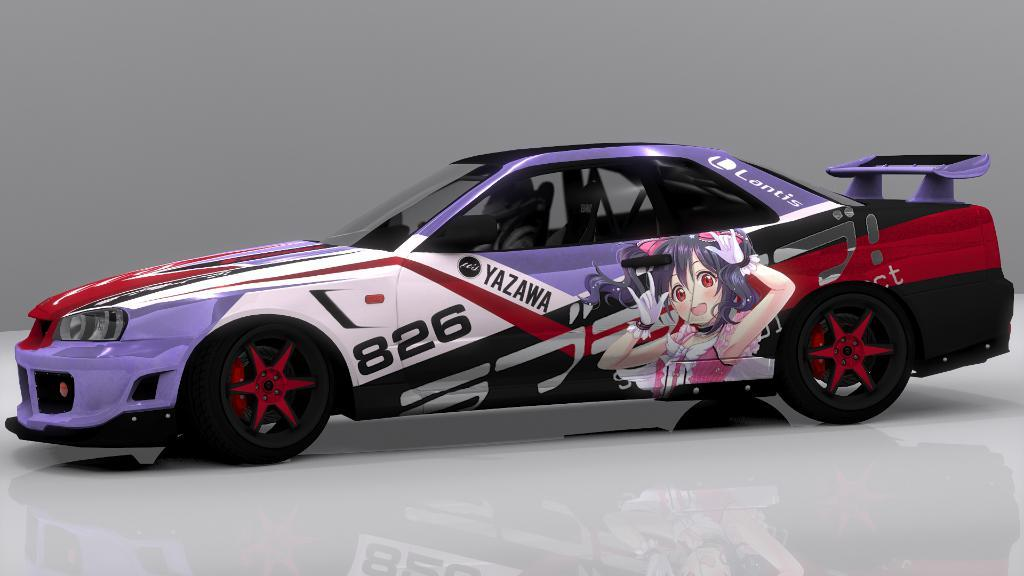What is the main subject of the image? The main subject of the image is a car. What is the color of the background in the image? The background of the image is white. What type of point is being made by the car in the image? There is no indication in the image that the car is making any point. Who is the expert in the image? There is no expert present in the image; it only features a car. What role does the car play in society in the image? The image does not depict any specific role of the car in society; it simply shows a car. 